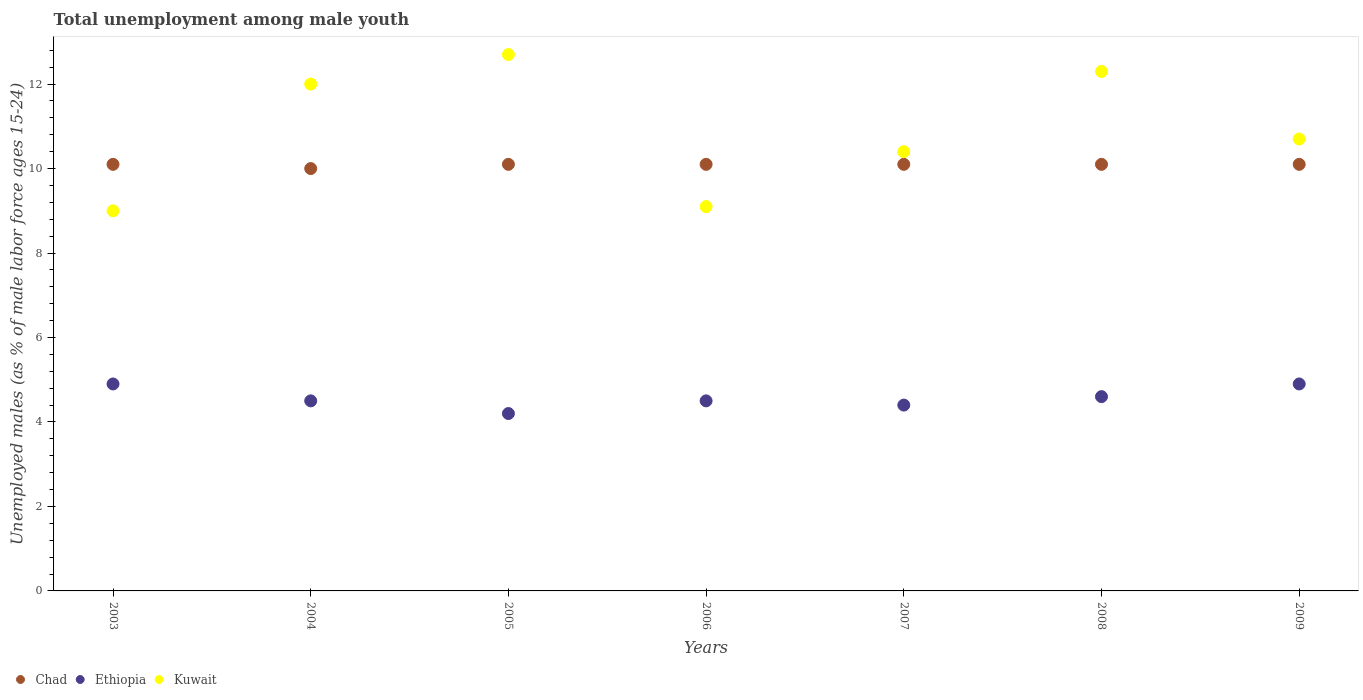How many different coloured dotlines are there?
Provide a succinct answer. 3. Is the number of dotlines equal to the number of legend labels?
Your response must be concise. Yes. What is the percentage of unemployed males in in Kuwait in 2009?
Ensure brevity in your answer.  10.7. Across all years, what is the maximum percentage of unemployed males in in Kuwait?
Your answer should be compact. 12.7. In which year was the percentage of unemployed males in in Ethiopia minimum?
Provide a succinct answer. 2005. What is the difference between the percentage of unemployed males in in Chad in 2004 and that in 2006?
Keep it short and to the point. -0.1. What is the difference between the percentage of unemployed males in in Chad in 2006 and the percentage of unemployed males in in Ethiopia in 2004?
Give a very brief answer. 5.6. What is the average percentage of unemployed males in in Kuwait per year?
Your answer should be compact. 10.89. In the year 2003, what is the difference between the percentage of unemployed males in in Chad and percentage of unemployed males in in Kuwait?
Offer a very short reply. 1.1. In how many years, is the percentage of unemployed males in in Ethiopia greater than 3.2 %?
Provide a short and direct response. 7. What is the ratio of the percentage of unemployed males in in Chad in 2003 to that in 2009?
Your answer should be compact. 1. Is the difference between the percentage of unemployed males in in Chad in 2006 and 2008 greater than the difference between the percentage of unemployed males in in Kuwait in 2006 and 2008?
Make the answer very short. Yes. What is the difference between the highest and the lowest percentage of unemployed males in in Ethiopia?
Keep it short and to the point. 0.7. In how many years, is the percentage of unemployed males in in Ethiopia greater than the average percentage of unemployed males in in Ethiopia taken over all years?
Provide a short and direct response. 3. Does the percentage of unemployed males in in Chad monotonically increase over the years?
Your response must be concise. No. What is the difference between two consecutive major ticks on the Y-axis?
Keep it short and to the point. 2. Are the values on the major ticks of Y-axis written in scientific E-notation?
Give a very brief answer. No. Does the graph contain grids?
Provide a succinct answer. No. How many legend labels are there?
Offer a very short reply. 3. How are the legend labels stacked?
Make the answer very short. Horizontal. What is the title of the graph?
Make the answer very short. Total unemployment among male youth. Does "Sierra Leone" appear as one of the legend labels in the graph?
Offer a terse response. No. What is the label or title of the X-axis?
Offer a very short reply. Years. What is the label or title of the Y-axis?
Ensure brevity in your answer.  Unemployed males (as % of male labor force ages 15-24). What is the Unemployed males (as % of male labor force ages 15-24) in Chad in 2003?
Offer a very short reply. 10.1. What is the Unemployed males (as % of male labor force ages 15-24) in Ethiopia in 2003?
Offer a very short reply. 4.9. What is the Unemployed males (as % of male labor force ages 15-24) in Kuwait in 2004?
Provide a short and direct response. 12. What is the Unemployed males (as % of male labor force ages 15-24) of Chad in 2005?
Give a very brief answer. 10.1. What is the Unemployed males (as % of male labor force ages 15-24) in Ethiopia in 2005?
Your answer should be very brief. 4.2. What is the Unemployed males (as % of male labor force ages 15-24) in Kuwait in 2005?
Your answer should be very brief. 12.7. What is the Unemployed males (as % of male labor force ages 15-24) in Chad in 2006?
Give a very brief answer. 10.1. What is the Unemployed males (as % of male labor force ages 15-24) in Kuwait in 2006?
Keep it short and to the point. 9.1. What is the Unemployed males (as % of male labor force ages 15-24) in Chad in 2007?
Your response must be concise. 10.1. What is the Unemployed males (as % of male labor force ages 15-24) in Ethiopia in 2007?
Offer a terse response. 4.4. What is the Unemployed males (as % of male labor force ages 15-24) in Kuwait in 2007?
Provide a succinct answer. 10.4. What is the Unemployed males (as % of male labor force ages 15-24) in Chad in 2008?
Provide a succinct answer. 10.1. What is the Unemployed males (as % of male labor force ages 15-24) in Ethiopia in 2008?
Keep it short and to the point. 4.6. What is the Unemployed males (as % of male labor force ages 15-24) of Kuwait in 2008?
Your response must be concise. 12.3. What is the Unemployed males (as % of male labor force ages 15-24) in Chad in 2009?
Your answer should be compact. 10.1. What is the Unemployed males (as % of male labor force ages 15-24) of Ethiopia in 2009?
Offer a terse response. 4.9. What is the Unemployed males (as % of male labor force ages 15-24) in Kuwait in 2009?
Ensure brevity in your answer.  10.7. Across all years, what is the maximum Unemployed males (as % of male labor force ages 15-24) in Chad?
Offer a terse response. 10.1. Across all years, what is the maximum Unemployed males (as % of male labor force ages 15-24) of Ethiopia?
Ensure brevity in your answer.  4.9. Across all years, what is the maximum Unemployed males (as % of male labor force ages 15-24) in Kuwait?
Ensure brevity in your answer.  12.7. Across all years, what is the minimum Unemployed males (as % of male labor force ages 15-24) in Ethiopia?
Ensure brevity in your answer.  4.2. What is the total Unemployed males (as % of male labor force ages 15-24) in Chad in the graph?
Your response must be concise. 70.6. What is the total Unemployed males (as % of male labor force ages 15-24) in Ethiopia in the graph?
Offer a terse response. 32. What is the total Unemployed males (as % of male labor force ages 15-24) of Kuwait in the graph?
Offer a terse response. 76.2. What is the difference between the Unemployed males (as % of male labor force ages 15-24) in Chad in 2003 and that in 2004?
Give a very brief answer. 0.1. What is the difference between the Unemployed males (as % of male labor force ages 15-24) of Kuwait in 2003 and that in 2004?
Provide a succinct answer. -3. What is the difference between the Unemployed males (as % of male labor force ages 15-24) of Ethiopia in 2003 and that in 2005?
Offer a very short reply. 0.7. What is the difference between the Unemployed males (as % of male labor force ages 15-24) of Chad in 2003 and that in 2006?
Offer a very short reply. 0. What is the difference between the Unemployed males (as % of male labor force ages 15-24) in Kuwait in 2003 and that in 2006?
Give a very brief answer. -0.1. What is the difference between the Unemployed males (as % of male labor force ages 15-24) in Ethiopia in 2003 and that in 2007?
Your answer should be very brief. 0.5. What is the difference between the Unemployed males (as % of male labor force ages 15-24) in Kuwait in 2003 and that in 2007?
Your response must be concise. -1.4. What is the difference between the Unemployed males (as % of male labor force ages 15-24) in Ethiopia in 2004 and that in 2005?
Your answer should be very brief. 0.3. What is the difference between the Unemployed males (as % of male labor force ages 15-24) in Kuwait in 2004 and that in 2005?
Your answer should be very brief. -0.7. What is the difference between the Unemployed males (as % of male labor force ages 15-24) in Kuwait in 2004 and that in 2007?
Your answer should be very brief. 1.6. What is the difference between the Unemployed males (as % of male labor force ages 15-24) of Chad in 2004 and that in 2008?
Your response must be concise. -0.1. What is the difference between the Unemployed males (as % of male labor force ages 15-24) in Kuwait in 2004 and that in 2008?
Make the answer very short. -0.3. What is the difference between the Unemployed males (as % of male labor force ages 15-24) of Kuwait in 2004 and that in 2009?
Ensure brevity in your answer.  1.3. What is the difference between the Unemployed males (as % of male labor force ages 15-24) of Chad in 2005 and that in 2006?
Your answer should be very brief. 0. What is the difference between the Unemployed males (as % of male labor force ages 15-24) in Ethiopia in 2005 and that in 2006?
Offer a very short reply. -0.3. What is the difference between the Unemployed males (as % of male labor force ages 15-24) in Ethiopia in 2005 and that in 2008?
Keep it short and to the point. -0.4. What is the difference between the Unemployed males (as % of male labor force ages 15-24) of Kuwait in 2005 and that in 2008?
Your answer should be compact. 0.4. What is the difference between the Unemployed males (as % of male labor force ages 15-24) of Chad in 2006 and that in 2007?
Your answer should be very brief. 0. What is the difference between the Unemployed males (as % of male labor force ages 15-24) in Chad in 2006 and that in 2008?
Ensure brevity in your answer.  0. What is the difference between the Unemployed males (as % of male labor force ages 15-24) of Ethiopia in 2006 and that in 2008?
Make the answer very short. -0.1. What is the difference between the Unemployed males (as % of male labor force ages 15-24) in Kuwait in 2006 and that in 2008?
Offer a terse response. -3.2. What is the difference between the Unemployed males (as % of male labor force ages 15-24) in Kuwait in 2006 and that in 2009?
Offer a terse response. -1.6. What is the difference between the Unemployed males (as % of male labor force ages 15-24) of Chad in 2007 and that in 2008?
Provide a succinct answer. 0. What is the difference between the Unemployed males (as % of male labor force ages 15-24) of Ethiopia in 2007 and that in 2008?
Offer a terse response. -0.2. What is the difference between the Unemployed males (as % of male labor force ages 15-24) in Kuwait in 2007 and that in 2009?
Your answer should be very brief. -0.3. What is the difference between the Unemployed males (as % of male labor force ages 15-24) of Chad in 2003 and the Unemployed males (as % of male labor force ages 15-24) of Ethiopia in 2005?
Provide a short and direct response. 5.9. What is the difference between the Unemployed males (as % of male labor force ages 15-24) of Chad in 2003 and the Unemployed males (as % of male labor force ages 15-24) of Kuwait in 2005?
Give a very brief answer. -2.6. What is the difference between the Unemployed males (as % of male labor force ages 15-24) in Chad in 2003 and the Unemployed males (as % of male labor force ages 15-24) in Kuwait in 2006?
Make the answer very short. 1. What is the difference between the Unemployed males (as % of male labor force ages 15-24) in Chad in 2003 and the Unemployed males (as % of male labor force ages 15-24) in Kuwait in 2008?
Provide a succinct answer. -2.2. What is the difference between the Unemployed males (as % of male labor force ages 15-24) in Chad in 2003 and the Unemployed males (as % of male labor force ages 15-24) in Ethiopia in 2009?
Your answer should be very brief. 5.2. What is the difference between the Unemployed males (as % of male labor force ages 15-24) of Chad in 2004 and the Unemployed males (as % of male labor force ages 15-24) of Ethiopia in 2005?
Offer a terse response. 5.8. What is the difference between the Unemployed males (as % of male labor force ages 15-24) in Chad in 2004 and the Unemployed males (as % of male labor force ages 15-24) in Kuwait in 2005?
Provide a short and direct response. -2.7. What is the difference between the Unemployed males (as % of male labor force ages 15-24) in Chad in 2004 and the Unemployed males (as % of male labor force ages 15-24) in Ethiopia in 2006?
Your response must be concise. 5.5. What is the difference between the Unemployed males (as % of male labor force ages 15-24) of Chad in 2004 and the Unemployed males (as % of male labor force ages 15-24) of Kuwait in 2006?
Offer a terse response. 0.9. What is the difference between the Unemployed males (as % of male labor force ages 15-24) of Chad in 2004 and the Unemployed males (as % of male labor force ages 15-24) of Ethiopia in 2007?
Ensure brevity in your answer.  5.6. What is the difference between the Unemployed males (as % of male labor force ages 15-24) in Ethiopia in 2004 and the Unemployed males (as % of male labor force ages 15-24) in Kuwait in 2007?
Offer a very short reply. -5.9. What is the difference between the Unemployed males (as % of male labor force ages 15-24) in Chad in 2004 and the Unemployed males (as % of male labor force ages 15-24) in Kuwait in 2008?
Your answer should be very brief. -2.3. What is the difference between the Unemployed males (as % of male labor force ages 15-24) in Ethiopia in 2004 and the Unemployed males (as % of male labor force ages 15-24) in Kuwait in 2008?
Ensure brevity in your answer.  -7.8. What is the difference between the Unemployed males (as % of male labor force ages 15-24) in Chad in 2004 and the Unemployed males (as % of male labor force ages 15-24) in Kuwait in 2009?
Offer a terse response. -0.7. What is the difference between the Unemployed males (as % of male labor force ages 15-24) in Ethiopia in 2004 and the Unemployed males (as % of male labor force ages 15-24) in Kuwait in 2009?
Offer a terse response. -6.2. What is the difference between the Unemployed males (as % of male labor force ages 15-24) of Chad in 2005 and the Unemployed males (as % of male labor force ages 15-24) of Ethiopia in 2006?
Keep it short and to the point. 5.6. What is the difference between the Unemployed males (as % of male labor force ages 15-24) in Ethiopia in 2005 and the Unemployed males (as % of male labor force ages 15-24) in Kuwait in 2006?
Your answer should be very brief. -4.9. What is the difference between the Unemployed males (as % of male labor force ages 15-24) of Chad in 2005 and the Unemployed males (as % of male labor force ages 15-24) of Ethiopia in 2008?
Ensure brevity in your answer.  5.5. What is the difference between the Unemployed males (as % of male labor force ages 15-24) of Chad in 2005 and the Unemployed males (as % of male labor force ages 15-24) of Kuwait in 2008?
Ensure brevity in your answer.  -2.2. What is the difference between the Unemployed males (as % of male labor force ages 15-24) in Ethiopia in 2005 and the Unemployed males (as % of male labor force ages 15-24) in Kuwait in 2008?
Your answer should be compact. -8.1. What is the difference between the Unemployed males (as % of male labor force ages 15-24) of Chad in 2005 and the Unemployed males (as % of male labor force ages 15-24) of Ethiopia in 2009?
Ensure brevity in your answer.  5.2. What is the difference between the Unemployed males (as % of male labor force ages 15-24) in Ethiopia in 2006 and the Unemployed males (as % of male labor force ages 15-24) in Kuwait in 2007?
Keep it short and to the point. -5.9. What is the difference between the Unemployed males (as % of male labor force ages 15-24) of Ethiopia in 2006 and the Unemployed males (as % of male labor force ages 15-24) of Kuwait in 2008?
Provide a succinct answer. -7.8. What is the difference between the Unemployed males (as % of male labor force ages 15-24) of Chad in 2006 and the Unemployed males (as % of male labor force ages 15-24) of Kuwait in 2009?
Your response must be concise. -0.6. What is the difference between the Unemployed males (as % of male labor force ages 15-24) in Ethiopia in 2006 and the Unemployed males (as % of male labor force ages 15-24) in Kuwait in 2009?
Ensure brevity in your answer.  -6.2. What is the difference between the Unemployed males (as % of male labor force ages 15-24) in Chad in 2007 and the Unemployed males (as % of male labor force ages 15-24) in Ethiopia in 2008?
Keep it short and to the point. 5.5. What is the difference between the Unemployed males (as % of male labor force ages 15-24) of Ethiopia in 2007 and the Unemployed males (as % of male labor force ages 15-24) of Kuwait in 2008?
Your answer should be compact. -7.9. What is the difference between the Unemployed males (as % of male labor force ages 15-24) in Chad in 2008 and the Unemployed males (as % of male labor force ages 15-24) in Ethiopia in 2009?
Provide a short and direct response. 5.2. What is the average Unemployed males (as % of male labor force ages 15-24) of Chad per year?
Offer a very short reply. 10.09. What is the average Unemployed males (as % of male labor force ages 15-24) of Ethiopia per year?
Offer a terse response. 4.57. What is the average Unemployed males (as % of male labor force ages 15-24) of Kuwait per year?
Offer a very short reply. 10.89. In the year 2003, what is the difference between the Unemployed males (as % of male labor force ages 15-24) in Chad and Unemployed males (as % of male labor force ages 15-24) in Kuwait?
Ensure brevity in your answer.  1.1. In the year 2003, what is the difference between the Unemployed males (as % of male labor force ages 15-24) in Ethiopia and Unemployed males (as % of male labor force ages 15-24) in Kuwait?
Your answer should be very brief. -4.1. In the year 2004, what is the difference between the Unemployed males (as % of male labor force ages 15-24) in Chad and Unemployed males (as % of male labor force ages 15-24) in Ethiopia?
Your answer should be compact. 5.5. In the year 2005, what is the difference between the Unemployed males (as % of male labor force ages 15-24) in Chad and Unemployed males (as % of male labor force ages 15-24) in Ethiopia?
Keep it short and to the point. 5.9. In the year 2005, what is the difference between the Unemployed males (as % of male labor force ages 15-24) of Ethiopia and Unemployed males (as % of male labor force ages 15-24) of Kuwait?
Offer a terse response. -8.5. In the year 2007, what is the difference between the Unemployed males (as % of male labor force ages 15-24) of Chad and Unemployed males (as % of male labor force ages 15-24) of Ethiopia?
Provide a short and direct response. 5.7. In the year 2007, what is the difference between the Unemployed males (as % of male labor force ages 15-24) in Chad and Unemployed males (as % of male labor force ages 15-24) in Kuwait?
Ensure brevity in your answer.  -0.3. In the year 2007, what is the difference between the Unemployed males (as % of male labor force ages 15-24) of Ethiopia and Unemployed males (as % of male labor force ages 15-24) of Kuwait?
Offer a very short reply. -6. In the year 2008, what is the difference between the Unemployed males (as % of male labor force ages 15-24) of Chad and Unemployed males (as % of male labor force ages 15-24) of Ethiopia?
Your answer should be very brief. 5.5. In the year 2008, what is the difference between the Unemployed males (as % of male labor force ages 15-24) in Ethiopia and Unemployed males (as % of male labor force ages 15-24) in Kuwait?
Provide a succinct answer. -7.7. In the year 2009, what is the difference between the Unemployed males (as % of male labor force ages 15-24) in Chad and Unemployed males (as % of male labor force ages 15-24) in Ethiopia?
Make the answer very short. 5.2. In the year 2009, what is the difference between the Unemployed males (as % of male labor force ages 15-24) of Ethiopia and Unemployed males (as % of male labor force ages 15-24) of Kuwait?
Ensure brevity in your answer.  -5.8. What is the ratio of the Unemployed males (as % of male labor force ages 15-24) in Chad in 2003 to that in 2004?
Your answer should be compact. 1.01. What is the ratio of the Unemployed males (as % of male labor force ages 15-24) of Ethiopia in 2003 to that in 2004?
Provide a short and direct response. 1.09. What is the ratio of the Unemployed males (as % of male labor force ages 15-24) of Kuwait in 2003 to that in 2004?
Make the answer very short. 0.75. What is the ratio of the Unemployed males (as % of male labor force ages 15-24) of Chad in 2003 to that in 2005?
Your response must be concise. 1. What is the ratio of the Unemployed males (as % of male labor force ages 15-24) in Kuwait in 2003 to that in 2005?
Provide a succinct answer. 0.71. What is the ratio of the Unemployed males (as % of male labor force ages 15-24) in Ethiopia in 2003 to that in 2006?
Make the answer very short. 1.09. What is the ratio of the Unemployed males (as % of male labor force ages 15-24) in Chad in 2003 to that in 2007?
Your answer should be very brief. 1. What is the ratio of the Unemployed males (as % of male labor force ages 15-24) in Ethiopia in 2003 to that in 2007?
Your response must be concise. 1.11. What is the ratio of the Unemployed males (as % of male labor force ages 15-24) in Kuwait in 2003 to that in 2007?
Your answer should be very brief. 0.87. What is the ratio of the Unemployed males (as % of male labor force ages 15-24) of Chad in 2003 to that in 2008?
Keep it short and to the point. 1. What is the ratio of the Unemployed males (as % of male labor force ages 15-24) of Ethiopia in 2003 to that in 2008?
Your answer should be compact. 1.07. What is the ratio of the Unemployed males (as % of male labor force ages 15-24) in Kuwait in 2003 to that in 2008?
Give a very brief answer. 0.73. What is the ratio of the Unemployed males (as % of male labor force ages 15-24) of Kuwait in 2003 to that in 2009?
Your response must be concise. 0.84. What is the ratio of the Unemployed males (as % of male labor force ages 15-24) of Ethiopia in 2004 to that in 2005?
Offer a terse response. 1.07. What is the ratio of the Unemployed males (as % of male labor force ages 15-24) of Kuwait in 2004 to that in 2005?
Your answer should be very brief. 0.94. What is the ratio of the Unemployed males (as % of male labor force ages 15-24) of Kuwait in 2004 to that in 2006?
Your answer should be compact. 1.32. What is the ratio of the Unemployed males (as % of male labor force ages 15-24) in Chad in 2004 to that in 2007?
Give a very brief answer. 0.99. What is the ratio of the Unemployed males (as % of male labor force ages 15-24) in Ethiopia in 2004 to that in 2007?
Offer a terse response. 1.02. What is the ratio of the Unemployed males (as % of male labor force ages 15-24) in Kuwait in 2004 to that in 2007?
Give a very brief answer. 1.15. What is the ratio of the Unemployed males (as % of male labor force ages 15-24) in Ethiopia in 2004 to that in 2008?
Offer a terse response. 0.98. What is the ratio of the Unemployed males (as % of male labor force ages 15-24) of Kuwait in 2004 to that in 2008?
Keep it short and to the point. 0.98. What is the ratio of the Unemployed males (as % of male labor force ages 15-24) in Ethiopia in 2004 to that in 2009?
Your answer should be very brief. 0.92. What is the ratio of the Unemployed males (as % of male labor force ages 15-24) in Kuwait in 2004 to that in 2009?
Your answer should be compact. 1.12. What is the ratio of the Unemployed males (as % of male labor force ages 15-24) of Chad in 2005 to that in 2006?
Provide a succinct answer. 1. What is the ratio of the Unemployed males (as % of male labor force ages 15-24) of Ethiopia in 2005 to that in 2006?
Your response must be concise. 0.93. What is the ratio of the Unemployed males (as % of male labor force ages 15-24) of Kuwait in 2005 to that in 2006?
Your answer should be very brief. 1.4. What is the ratio of the Unemployed males (as % of male labor force ages 15-24) of Ethiopia in 2005 to that in 2007?
Your answer should be compact. 0.95. What is the ratio of the Unemployed males (as % of male labor force ages 15-24) of Kuwait in 2005 to that in 2007?
Provide a short and direct response. 1.22. What is the ratio of the Unemployed males (as % of male labor force ages 15-24) in Chad in 2005 to that in 2008?
Offer a very short reply. 1. What is the ratio of the Unemployed males (as % of male labor force ages 15-24) of Kuwait in 2005 to that in 2008?
Your answer should be very brief. 1.03. What is the ratio of the Unemployed males (as % of male labor force ages 15-24) in Ethiopia in 2005 to that in 2009?
Your response must be concise. 0.86. What is the ratio of the Unemployed males (as % of male labor force ages 15-24) in Kuwait in 2005 to that in 2009?
Keep it short and to the point. 1.19. What is the ratio of the Unemployed males (as % of male labor force ages 15-24) in Chad in 2006 to that in 2007?
Ensure brevity in your answer.  1. What is the ratio of the Unemployed males (as % of male labor force ages 15-24) in Ethiopia in 2006 to that in 2007?
Keep it short and to the point. 1.02. What is the ratio of the Unemployed males (as % of male labor force ages 15-24) of Kuwait in 2006 to that in 2007?
Your response must be concise. 0.88. What is the ratio of the Unemployed males (as % of male labor force ages 15-24) in Chad in 2006 to that in 2008?
Keep it short and to the point. 1. What is the ratio of the Unemployed males (as % of male labor force ages 15-24) in Ethiopia in 2006 to that in 2008?
Your response must be concise. 0.98. What is the ratio of the Unemployed males (as % of male labor force ages 15-24) of Kuwait in 2006 to that in 2008?
Your answer should be compact. 0.74. What is the ratio of the Unemployed males (as % of male labor force ages 15-24) of Chad in 2006 to that in 2009?
Your answer should be compact. 1. What is the ratio of the Unemployed males (as % of male labor force ages 15-24) of Ethiopia in 2006 to that in 2009?
Your answer should be very brief. 0.92. What is the ratio of the Unemployed males (as % of male labor force ages 15-24) in Kuwait in 2006 to that in 2009?
Provide a short and direct response. 0.85. What is the ratio of the Unemployed males (as % of male labor force ages 15-24) in Ethiopia in 2007 to that in 2008?
Your answer should be compact. 0.96. What is the ratio of the Unemployed males (as % of male labor force ages 15-24) of Kuwait in 2007 to that in 2008?
Offer a very short reply. 0.85. What is the ratio of the Unemployed males (as % of male labor force ages 15-24) in Ethiopia in 2007 to that in 2009?
Offer a terse response. 0.9. What is the ratio of the Unemployed males (as % of male labor force ages 15-24) of Kuwait in 2007 to that in 2009?
Your answer should be very brief. 0.97. What is the ratio of the Unemployed males (as % of male labor force ages 15-24) of Ethiopia in 2008 to that in 2009?
Offer a terse response. 0.94. What is the ratio of the Unemployed males (as % of male labor force ages 15-24) in Kuwait in 2008 to that in 2009?
Keep it short and to the point. 1.15. What is the difference between the highest and the second highest Unemployed males (as % of male labor force ages 15-24) in Chad?
Keep it short and to the point. 0. What is the difference between the highest and the second highest Unemployed males (as % of male labor force ages 15-24) of Kuwait?
Offer a terse response. 0.4. What is the difference between the highest and the lowest Unemployed males (as % of male labor force ages 15-24) in Chad?
Keep it short and to the point. 0.1. 